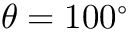<formula> <loc_0><loc_0><loc_500><loc_500>\theta = 1 0 0 ^ { \circ }</formula> 